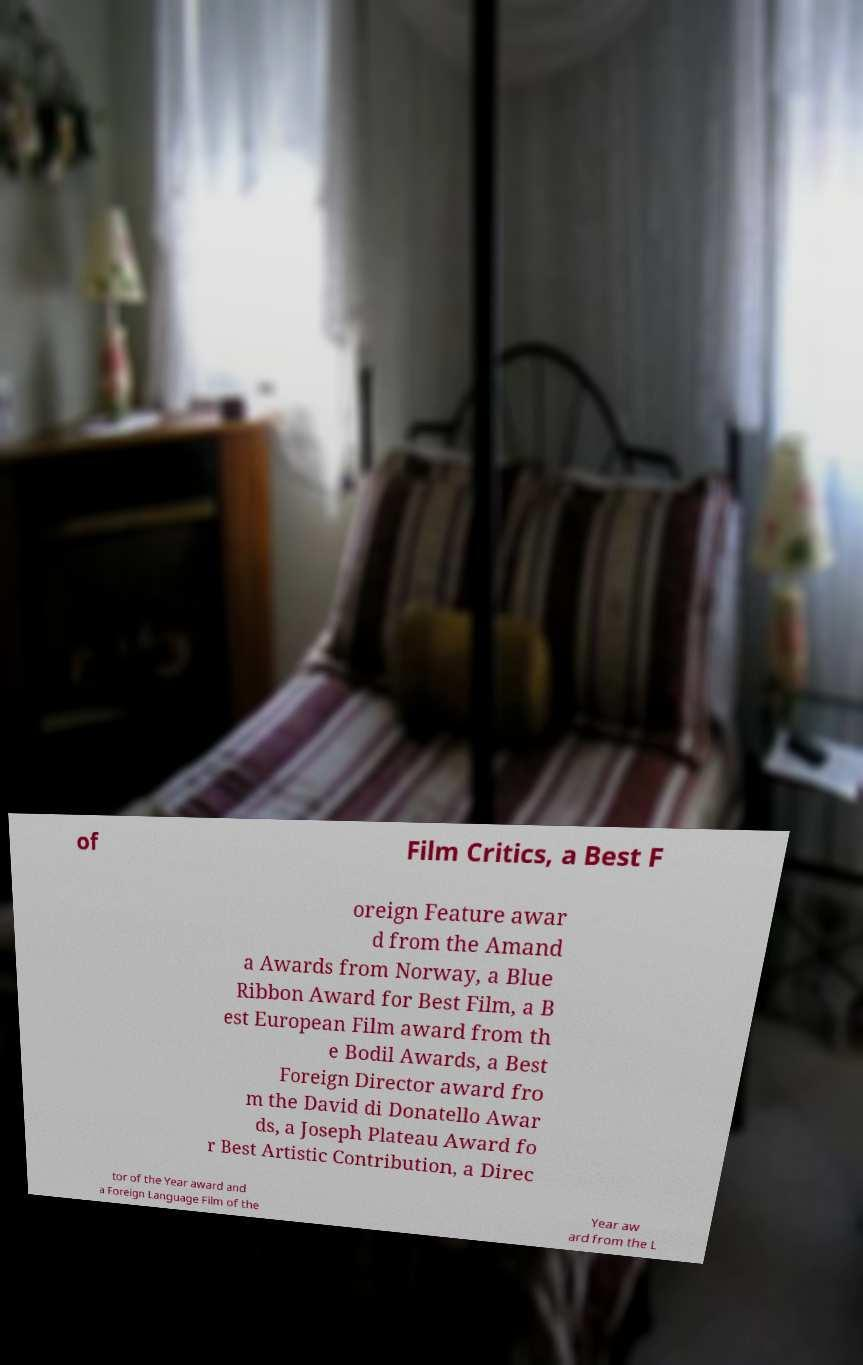There's text embedded in this image that I need extracted. Can you transcribe it verbatim? of Film Critics, a Best F oreign Feature awar d from the Amand a Awards from Norway, a Blue Ribbon Award for Best Film, a B est European Film award from th e Bodil Awards, a Best Foreign Director award fro m the David di Donatello Awar ds, a Joseph Plateau Award fo r Best Artistic Contribution, a Direc tor of the Year award and a Foreign Language Film of the Year aw ard from the L 